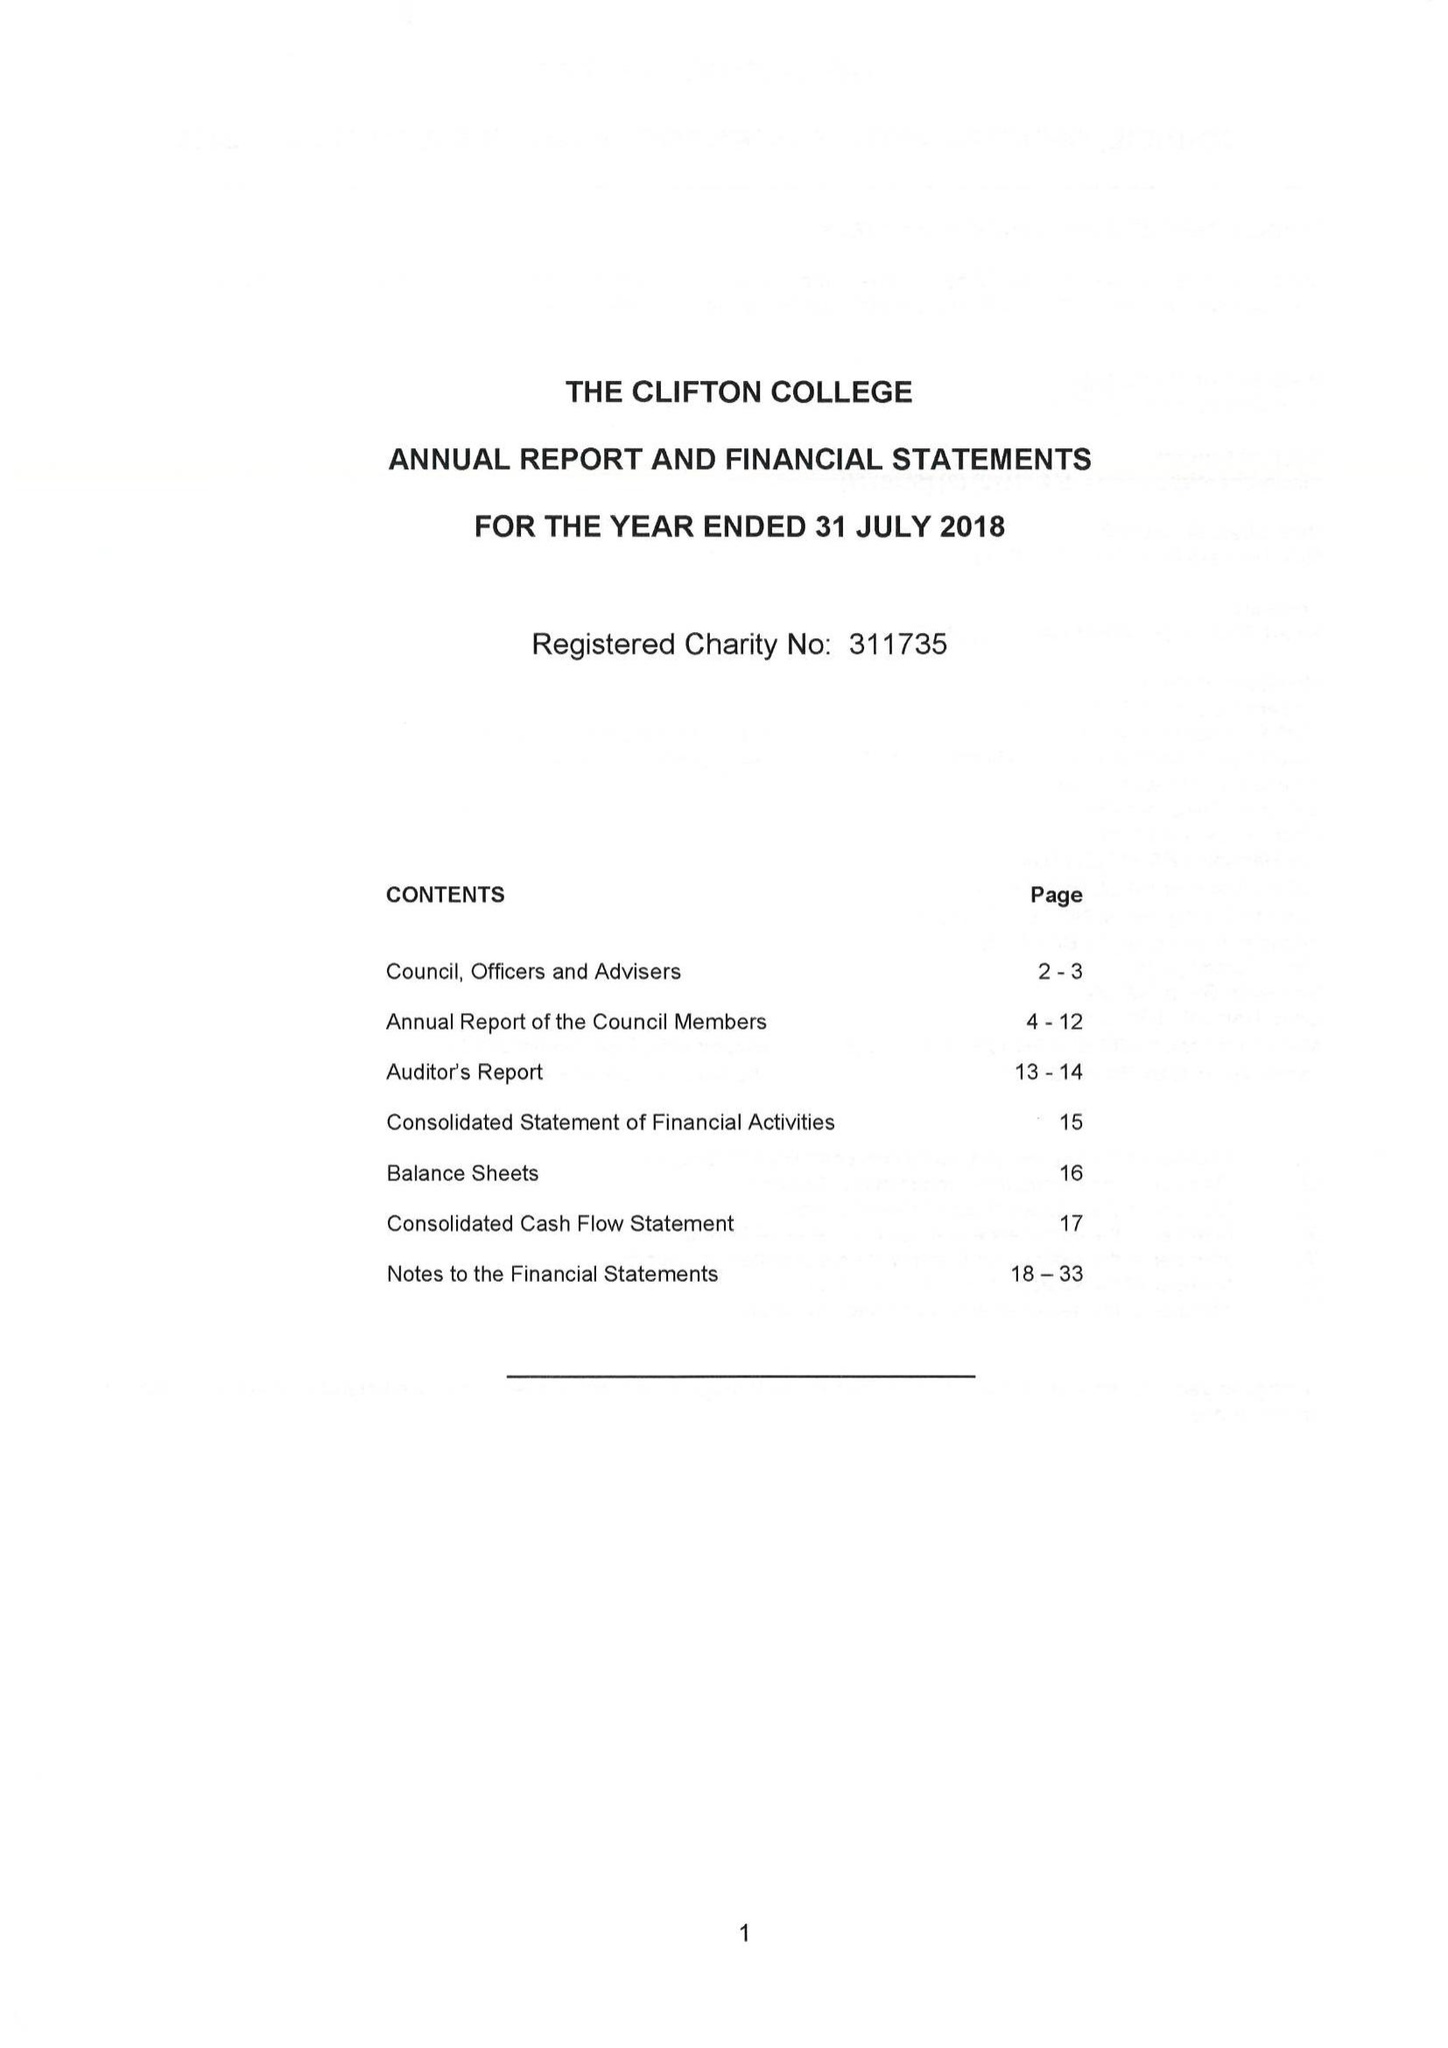What is the value for the charity_number?
Answer the question using a single word or phrase. 311735 